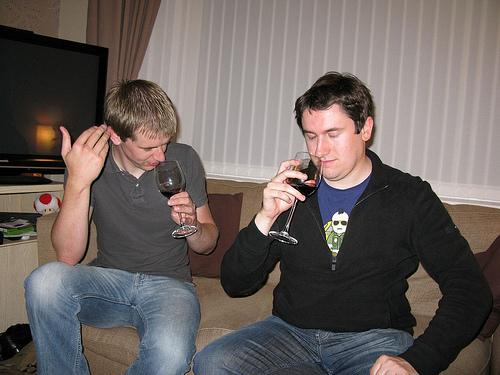Identify the object the man is holding and where they are sitting. The man is holding a wine glass and they are sitting on a light brown sofa. Describe the overall scene depicted in the image. Two men are sitting on a light brown sofa drinking wine while a television monitor and a window with curtains are in the background. What are the men doing in the image? The men are sitting on a sofa, drinking wine and discussing. What can be seen in the background of the image, close to the men? A television monitor, curtains by a window, and a pillow on the couch can be seen in the background. What action is the man wearing a black jacket performing with the wine glass? The man wearing a black jacket is tilting the wine glass. What is the primary color of the man's jeans? The man is wearing blue jeans. What is the relationship between the nose and the wine glass? The man is smelling the wine by putting his nose in the glass. List two clothing items the men are wearing in the image. A black jacket and a grey shirt are being worn by the men in the image. Describe the appearance of the wine held by the man. The wine is dark and red in color, held in a glass. What is the object located near the couch with the men? A stuffed toad character is located near the couch with the men. 